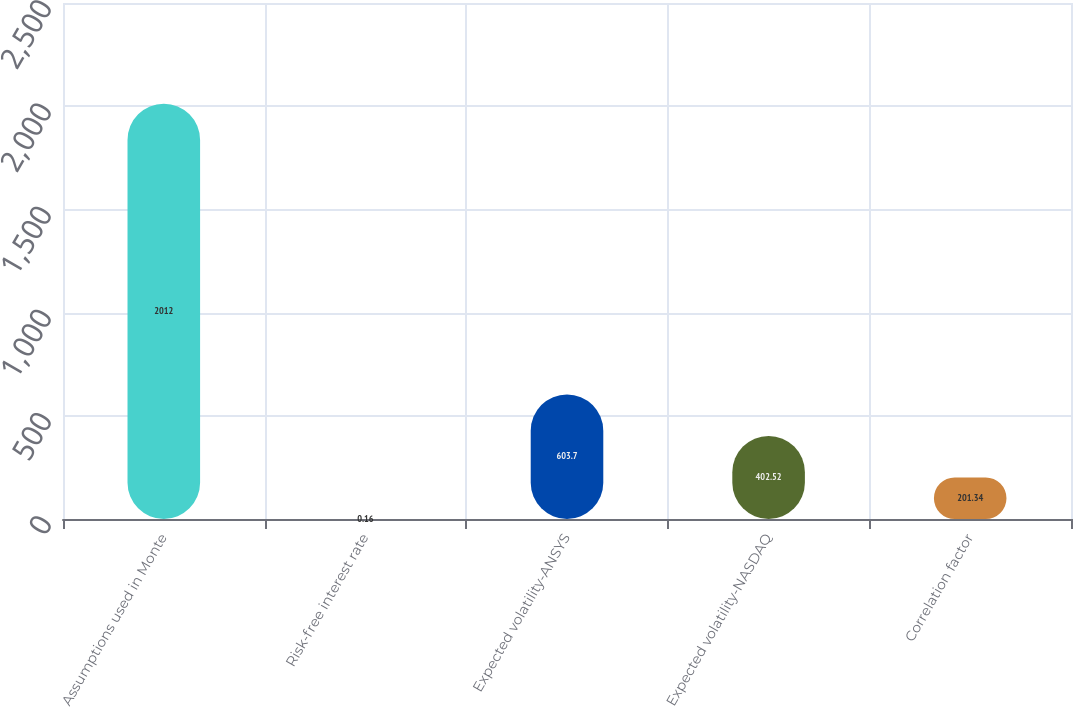<chart> <loc_0><loc_0><loc_500><loc_500><bar_chart><fcel>Assumptions used in Monte<fcel>Risk-free interest rate<fcel>Expected volatility-ANSYS<fcel>Expected volatility-NASDAQ<fcel>Correlation factor<nl><fcel>2012<fcel>0.16<fcel>603.7<fcel>402.52<fcel>201.34<nl></chart> 